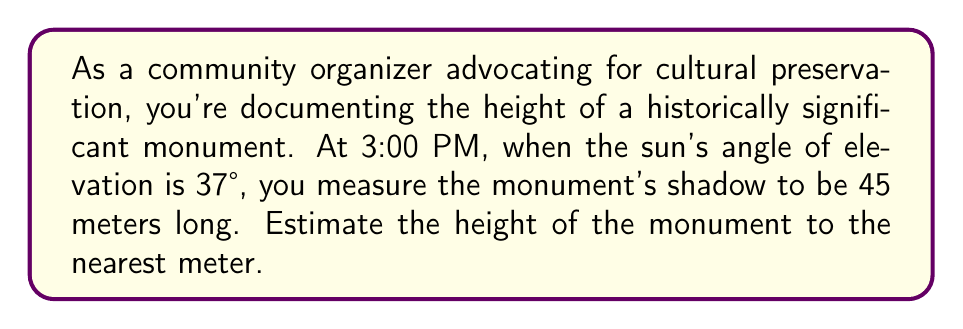Could you help me with this problem? Let's approach this step-by-step using trigonometry:

1) We can model this situation as a right triangle, where:
   - The monument's height is the opposite side
   - The shadow's length is the adjacent side
   - The sun's rays form the hypotenuse

2) Given:
   - Sun's angle of elevation: $\theta = 37°$
   - Shadow length: $\text{adjacent} = 45$ meters

3) We need to find the opposite side (monument's height). The trigonometric ratio that relates the opposite and adjacent sides is tangent:

   $$\tan \theta = \frac{\text{opposite}}{\text{adjacent}}$$

4) Rearranging this equation:

   $$\text{opposite} = \text{adjacent} \times \tan \theta$$

5) Substituting our known values:

   $$\text{height} = 45 \times \tan 37°$$

6) Using a calculator or trigonometric table:

   $$\text{height} = 45 \times 0.7536 \approx 33.912 \text{ meters}$$

7) Rounding to the nearest meter:

   $$\text{height} \approx 34 \text{ meters}$$

This method allows for non-invasive measurement of historical structures, aiding in their documentation and preservation.
Answer: 34 meters 